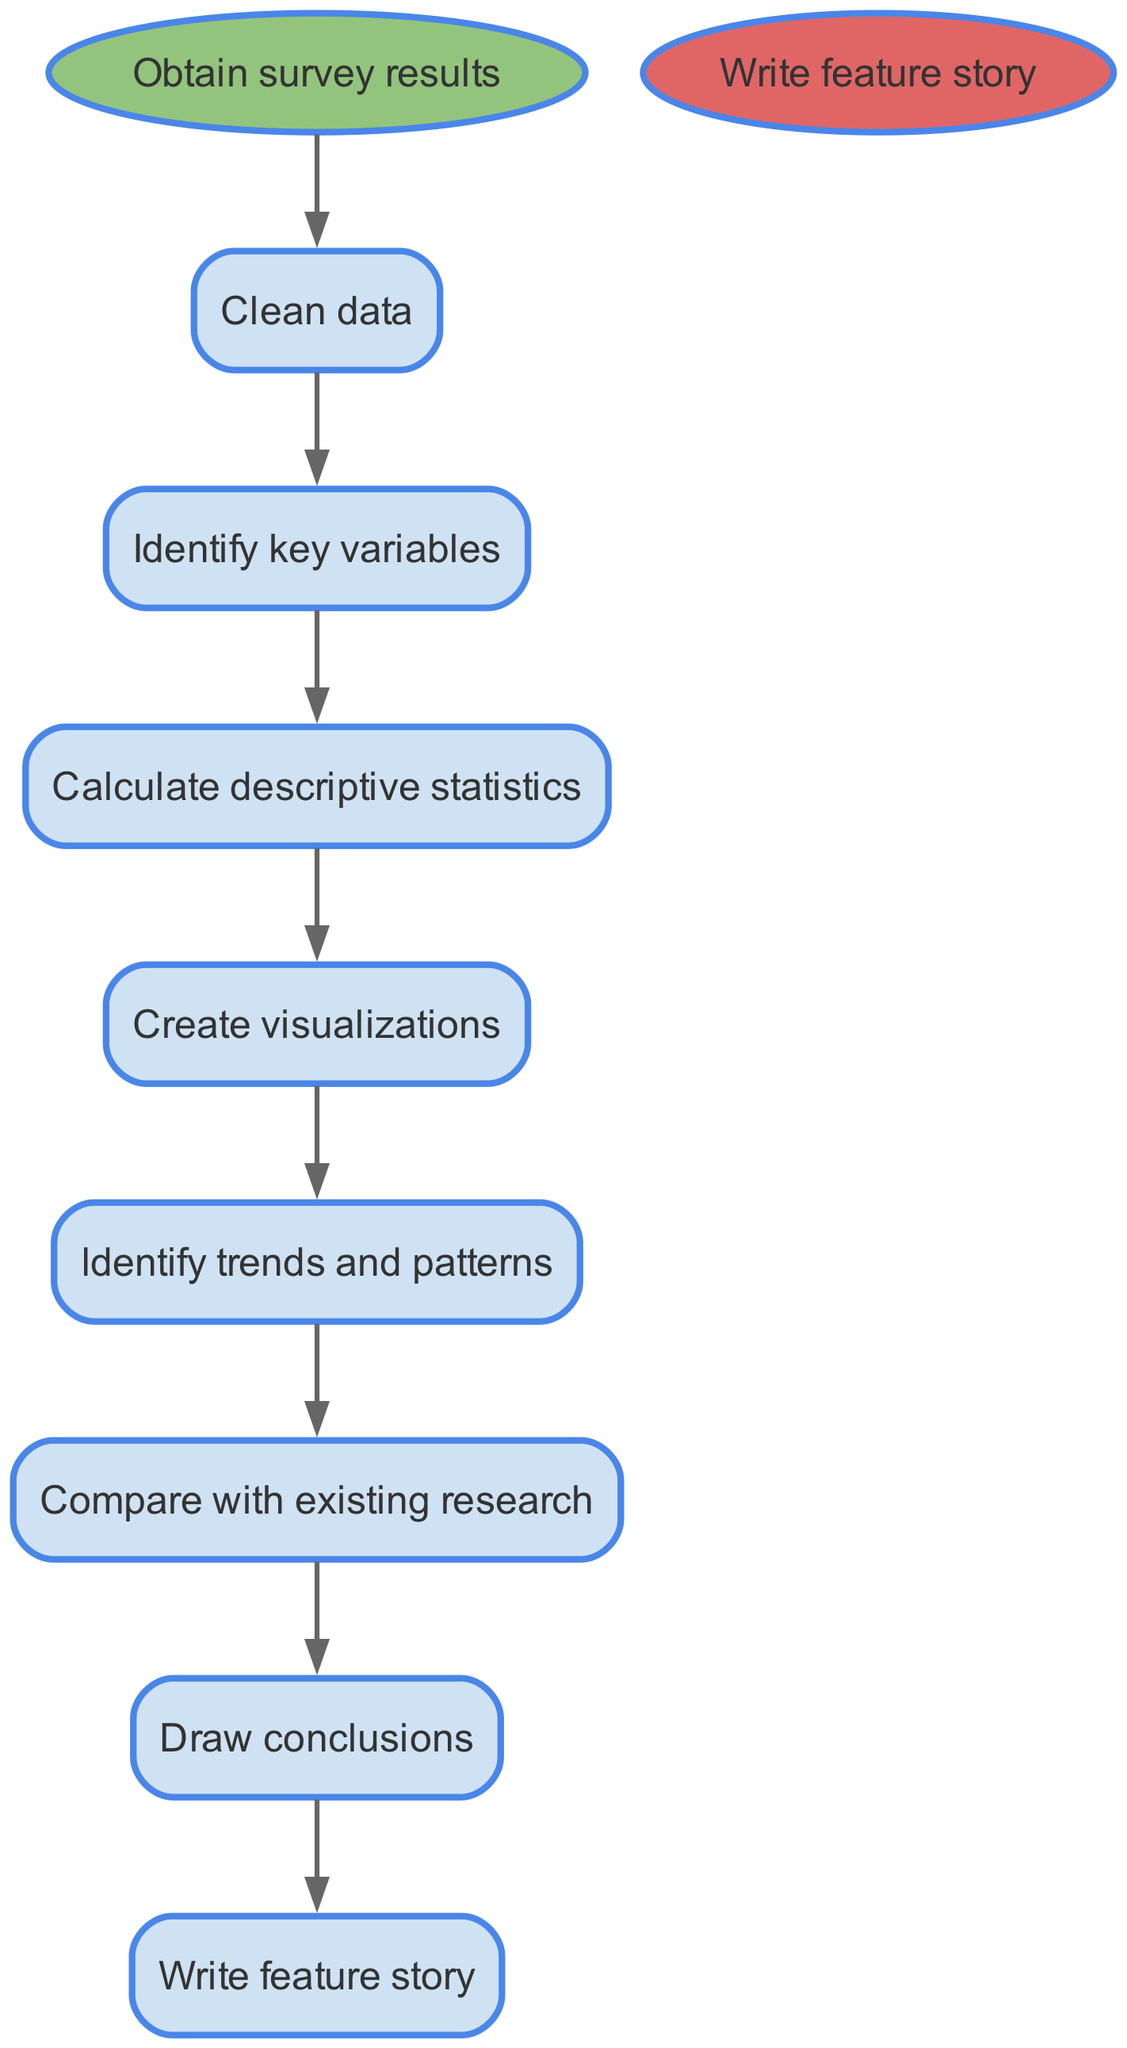What is the first step in analyzing survey results? The first step in the flow chart is labeled as "Obtain survey results," which serves as the starting point for the process.
Answer: Obtain survey results How many process nodes are there in the diagram? The diagram contains six process nodes, which include the steps labeled: Clean data, Identify key variables, Calculate descriptive statistics, Create visualizations, Identify trends and patterns, and Compare with existing research.
Answer: Six What follows after "Clean data"? According to the flow chart, after "Clean data," the next step is "Identify key variables," which indicates the progression of the analysis flow.
Answer: Identify key variables Which step leads to "Write feature story"? The final step that leads to "Write feature story" is "Draw conclusions," connecting the analytical process to the final output of the feature article.
Answer: Draw conclusions What step comes before "Identify trends and patterns"? Prior to "Identify trends and patterns," the step is "Create visualizations." This shows that creating visual data representations is essential before trend analysis occurs.
Answer: Create visualizations What is the relationship between "Compare with existing research" and "Draw conclusions"? "Compare with existing research" directly precedes "Draw conclusions," indicating that research comparison is essential for forming conclusions based on the analysis performed.
Answer: Directly precedes What is the last step in the process? The last step in the diagram is labeled as "Write feature story," signifying the culmination of the analysis process into a published article.
Answer: Write feature story Which step has the most connections to the next steps? The step "Identify key variables" has the most connections, as it flows into "Calculate descriptive statistics," thereby linking to subsequent steps in the analysis process.
Answer: Identify key variables What is indicated by the flow from "Create visualizations" to "Identify trends and patterns"? The flow from "Create visualizations" to "Identify trends and patterns" indicates that visualizations are a crucial tool for recognizing trends and patterns within the survey data analyzed.
Answer: Visualizations are crucial 